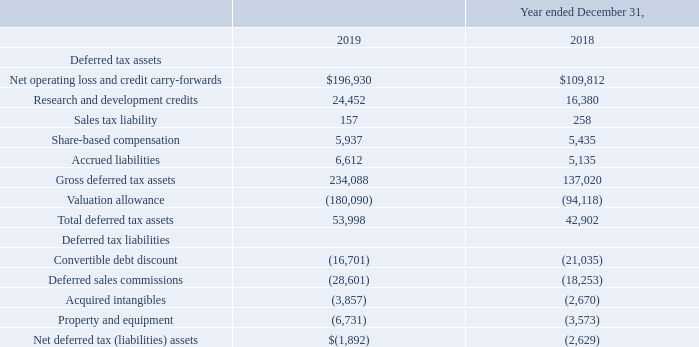The types of temporary differences that give rise to significant portions of the Company’s deferred tax assets and liabilities are as follows (in thousands):
On December 22, 2017, the Tax Cuts and Jobs Act of 2017 (the “Act”) was signed into law making significant changes to the Internal Revenue Code. Changes include, but are not limited to, a corporate tax rate decrease from 35% to 21% effective for tax years beginning after December 31, 2017, the transition of U.S. international taxation from a worldwide tax system to a territorial system, and a one-time transition tax on the mandatory deemed repatriation of cumulative foreign earnings as of December 31, 2017.
In connection with the acquisition of Connect First on January 14, 2019, a net deferred tax liability of $3.2 million was established, the most significant component of which is related to the book/tax basis differences associated with the acquired technology and customer relationships. The net deferred tax liability from this acquisition created an additional source of income to realize deferred tax assets. As the Company continues to maintain a full valuation allowance against its deferred tax assets, this additional source of income resulted in the release of the Company’s previously recorded valuation allowance against deferred assets. Consistent with the applicable guidance the release of the valuation allowance of $3.2 million caused by the acquisition was recorded in the consolidated financial statements outside of acquisition accounting as a tax benefit to the Consolidated Statements of Operations.
As of December 31, 2019, the Company has federal net operating loss carryforwards of approximately $782.7 million, of which approximately $272.9 million expire between 2023 and 2037 and the remainder do not expire. As of December 31, 2019, the Company had state net operating loss carryforwards of approximately $675.6 million which will begin to expire in 2021. The Company also has research credit carryforwards for federal and California tax purposes of approximately $20.2 million and $15.7 million, respectively, available to reduce future income subject to income taxes. The federal research credit carryforwards will begin to expire in 2028 and the California research credits carry forward indefinitely
The Internal Revenue Code of 1986, as amended, imposes restrictions on the utilization of net operating losses in the event of an “ownership change” of a corporation. Accordingly, a company’s ability to use net operating losses may be limited as prescribed under Internal Revenue Code Section 382 (“IRC Section 382”). Events which may cause limitations in the amount of the net operating losses that the Company may use in any one year include, but are not limited to, a cumulative ownership change of more than 50% over a three-year period. Utilization of the federal and state net operating losses may be subject to substantial annual limitation due to the ownership change limitations provided by the IRC Section 382 and similar state provisions
The Company’s management believes that, based on a number of factors, it is more likely than not, that all or some portion of the deferred tax assets will not be realized; and accordingly, for the year ended December 31, 2019, the Company has provided a valuation allowance against the Company’s U.S. net deferred tax assets. The net change in the valuation allowance for the years ended December 31, 2019 and 2018 was an increase of $86.0 million, $18.2 million, respectively
What is the respective net increase in the valuation allowance for the years ended December 31, 2019 and 2018? $86.0 million, $18.2 million. What are the respective net operating loss and credit carry-forwards for 2018 and 2019?
Answer scale should be: thousand. $109,812, $196,930. What are the respective research and development credits in 2018 and 2019?
Answer scale should be: thousand. 16,380, 24,452. What is the percentage change in the company's net operating loss and credit carry-forwards between 2018 and 2019?
Answer scale should be: percent. (196,930 - 109,812)/109,812 
Answer: 79.33. What is the percentage change in the company's sales tax liability between 2018 and 2019?
Answer scale should be: percent. (157 - 258)/258 
Answer: -39.15. What is the average share based compensation in 2018 and 2019?
Answer scale should be: thousand. (5,937 + 5,435)/2
Answer: 5686. 